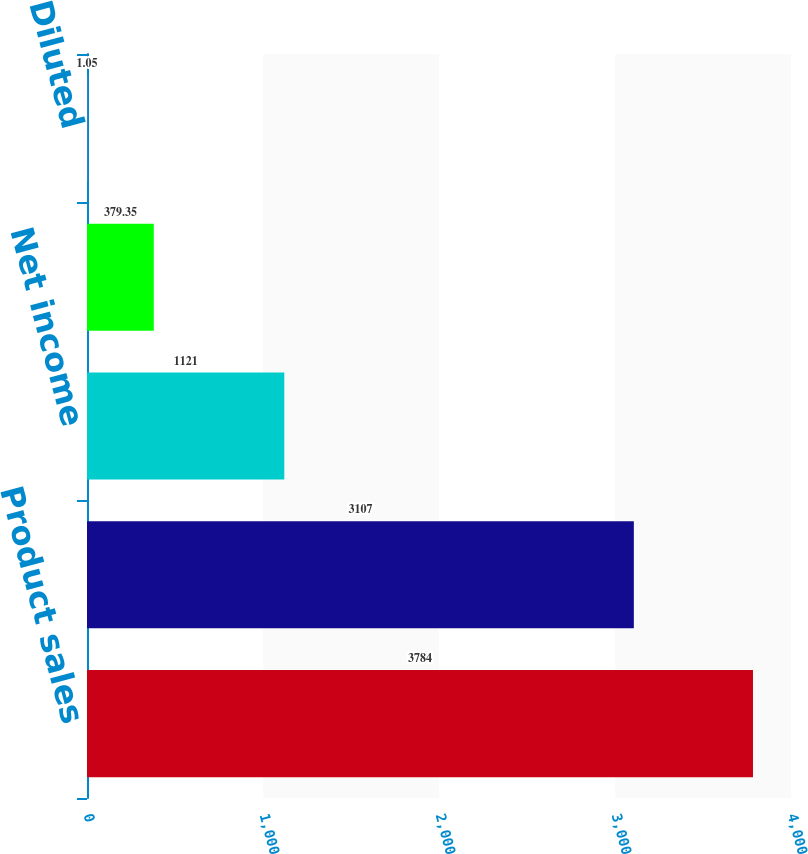Convert chart. <chart><loc_0><loc_0><loc_500><loc_500><bar_chart><fcel>Product sales<fcel>Gross profit from product<fcel>Net income<fcel>Basic<fcel>Diluted<nl><fcel>3784<fcel>3107<fcel>1121<fcel>379.35<fcel>1.05<nl></chart> 